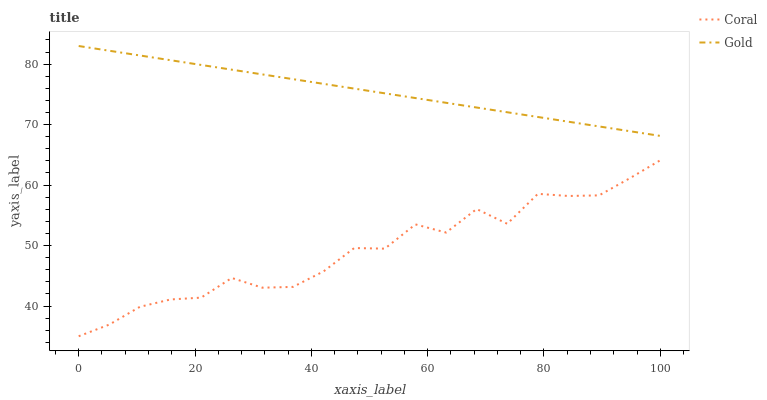Does Gold have the minimum area under the curve?
Answer yes or no. No. Is Gold the roughest?
Answer yes or no. No. Does Gold have the lowest value?
Answer yes or no. No. Is Coral less than Gold?
Answer yes or no. Yes. Is Gold greater than Coral?
Answer yes or no. Yes. Does Coral intersect Gold?
Answer yes or no. No. 